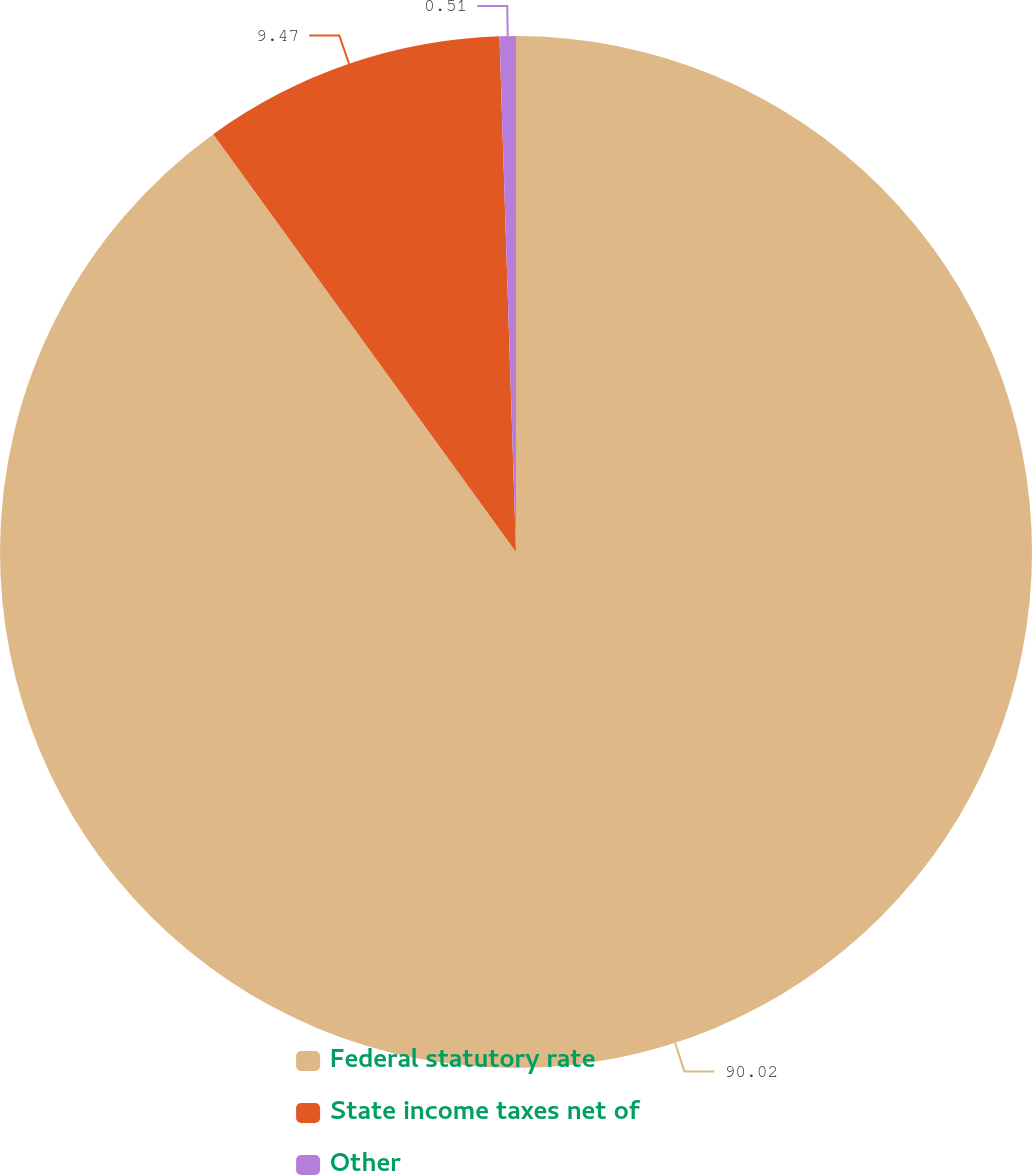Convert chart. <chart><loc_0><loc_0><loc_500><loc_500><pie_chart><fcel>Federal statutory rate<fcel>State income taxes net of<fcel>Other<nl><fcel>90.02%<fcel>9.47%<fcel>0.51%<nl></chart> 